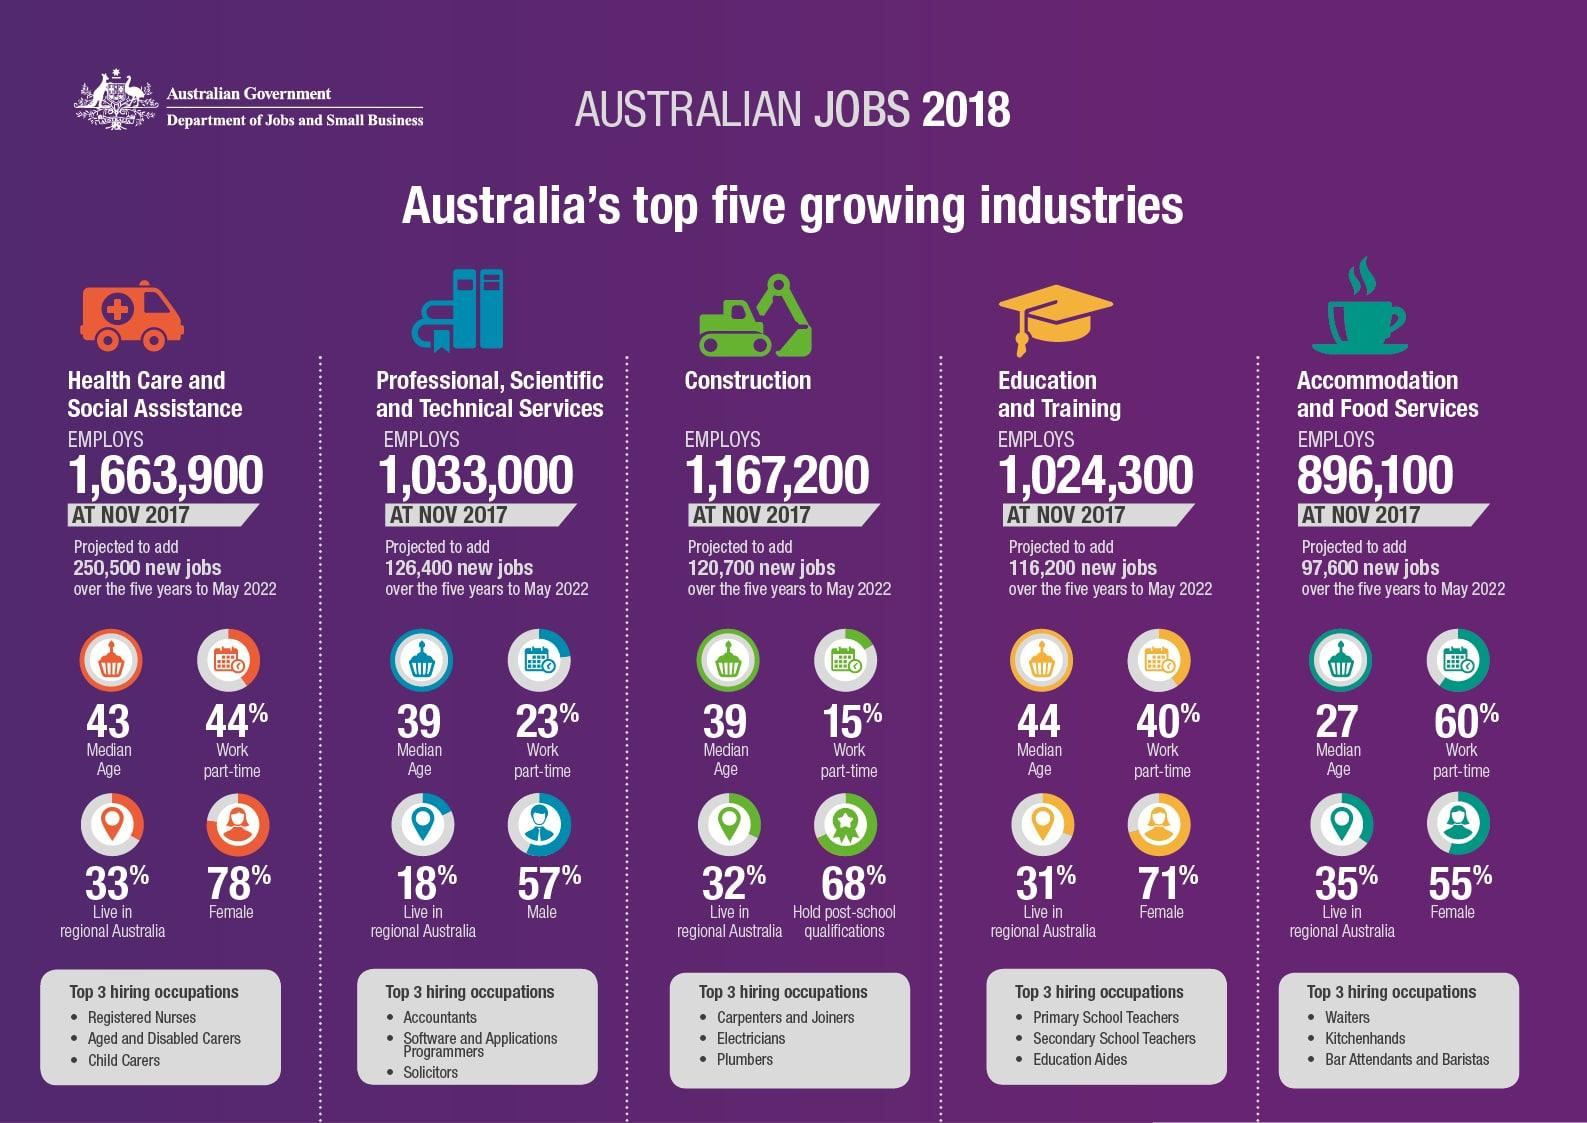Highlight a few significant elements in this photo. In 2018, approximately 23% of employees in the Professional, Scientific and Technical Services industry in Australia worked part-time. In 2018, 31% of employees working in education and training institutions in regional Australia lived in those areas. In November 2017, there were approximately 1,024,300 employees working in education and training institutions in Australia. In 2018, 33% of employees working in the health care and social assistance services resided in regional Australia. In 2018, 55% of female employees were working in the Accommodation and Food Services sector in Australia. 